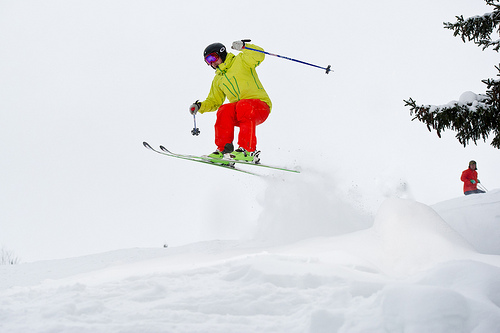Please provide the bounding box coordinate of the region this sentence describes: yellow jacket on skier. The bright yellow jacket, worn by the skier as they leap through the air, can be identified within the bounding box [0.4, 0.25, 0.55, 0.39]. 